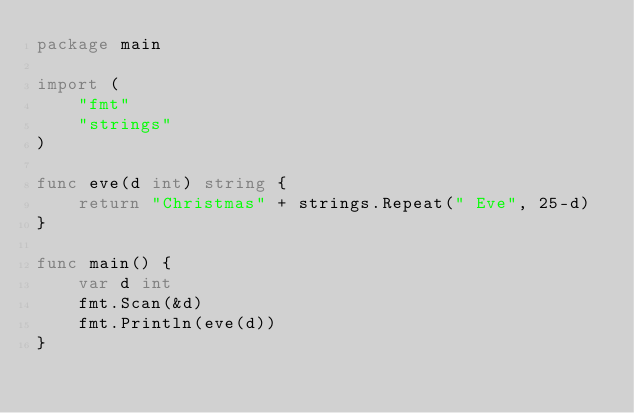Convert code to text. <code><loc_0><loc_0><loc_500><loc_500><_Go_>package main

import (
	"fmt"
	"strings"
)

func eve(d int) string {
	return "Christmas" + strings.Repeat(" Eve", 25-d)
}

func main() {
	var d int
	fmt.Scan(&d)
	fmt.Println(eve(d))
}
</code> 